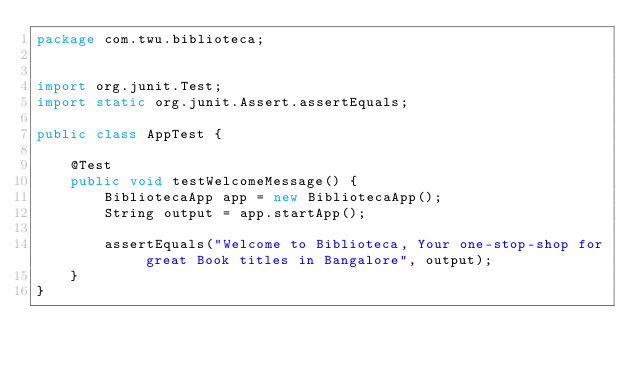<code> <loc_0><loc_0><loc_500><loc_500><_Java_>package com.twu.biblioteca;


import org.junit.Test;
import static org.junit.Assert.assertEquals;

public class AppTest {

    @Test
    public void testWelcomeMessage() {
        BibliotecaApp app = new BibliotecaApp();
        String output = app.startApp();

        assertEquals("Welcome to Biblioteca, Your one-stop-shop for great Book titles in Bangalore", output);
    }
}
</code> 